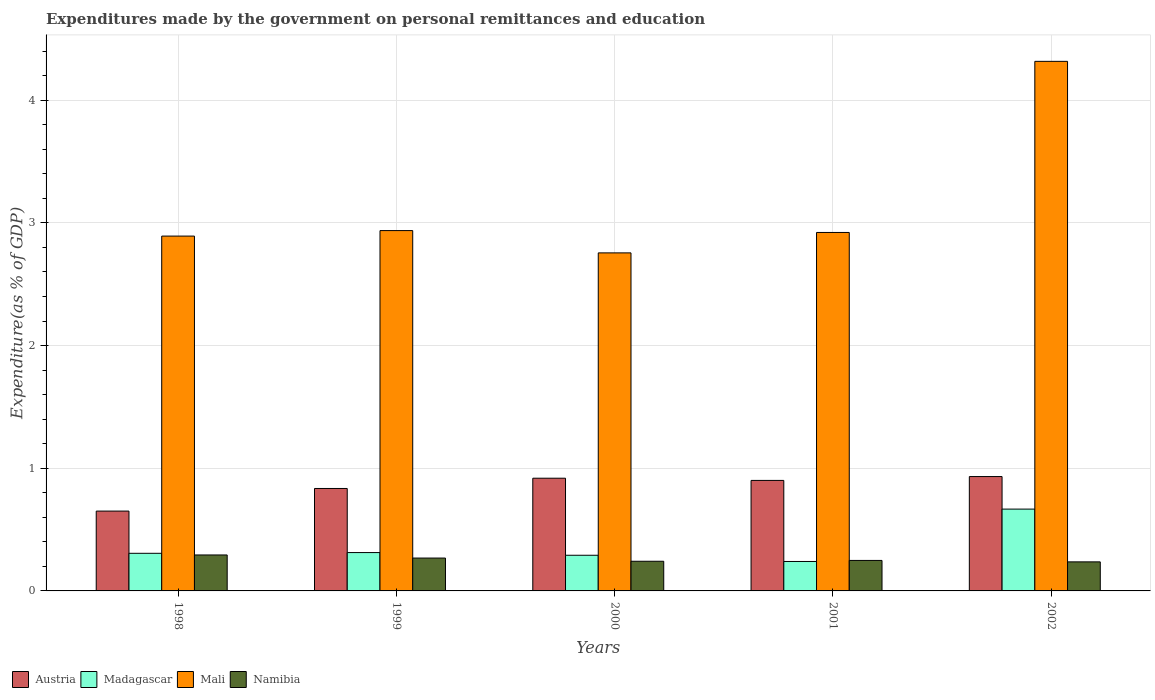How many bars are there on the 3rd tick from the right?
Your answer should be compact. 4. In how many cases, is the number of bars for a given year not equal to the number of legend labels?
Your answer should be compact. 0. What is the expenditures made by the government on personal remittances and education in Namibia in 2002?
Ensure brevity in your answer.  0.24. Across all years, what is the maximum expenditures made by the government on personal remittances and education in Madagascar?
Provide a short and direct response. 0.67. Across all years, what is the minimum expenditures made by the government on personal remittances and education in Madagascar?
Your answer should be compact. 0.24. In which year was the expenditures made by the government on personal remittances and education in Madagascar maximum?
Offer a very short reply. 2002. What is the total expenditures made by the government on personal remittances and education in Namibia in the graph?
Give a very brief answer. 1.29. What is the difference between the expenditures made by the government on personal remittances and education in Austria in 1998 and that in 1999?
Your answer should be very brief. -0.18. What is the difference between the expenditures made by the government on personal remittances and education in Austria in 1998 and the expenditures made by the government on personal remittances and education in Mali in 2001?
Your answer should be very brief. -2.27. What is the average expenditures made by the government on personal remittances and education in Madagascar per year?
Offer a very short reply. 0.36. In the year 2002, what is the difference between the expenditures made by the government on personal remittances and education in Austria and expenditures made by the government on personal remittances and education in Mali?
Your answer should be very brief. -3.38. What is the ratio of the expenditures made by the government on personal remittances and education in Madagascar in 1998 to that in 2000?
Provide a succinct answer. 1.05. Is the difference between the expenditures made by the government on personal remittances and education in Austria in 1999 and 2001 greater than the difference between the expenditures made by the government on personal remittances and education in Mali in 1999 and 2001?
Your answer should be compact. No. What is the difference between the highest and the second highest expenditures made by the government on personal remittances and education in Mali?
Your answer should be very brief. 1.38. What is the difference between the highest and the lowest expenditures made by the government on personal remittances and education in Austria?
Offer a very short reply. 0.28. In how many years, is the expenditures made by the government on personal remittances and education in Madagascar greater than the average expenditures made by the government on personal remittances and education in Madagascar taken over all years?
Your response must be concise. 1. Is the sum of the expenditures made by the government on personal remittances and education in Namibia in 2001 and 2002 greater than the maximum expenditures made by the government on personal remittances and education in Austria across all years?
Offer a terse response. No. Is it the case that in every year, the sum of the expenditures made by the government on personal remittances and education in Namibia and expenditures made by the government on personal remittances and education in Austria is greater than the sum of expenditures made by the government on personal remittances and education in Mali and expenditures made by the government on personal remittances and education in Madagascar?
Keep it short and to the point. No. What does the 4th bar from the left in 1998 represents?
Ensure brevity in your answer.  Namibia. What does the 3rd bar from the right in 1998 represents?
Provide a short and direct response. Madagascar. Is it the case that in every year, the sum of the expenditures made by the government on personal remittances and education in Madagascar and expenditures made by the government on personal remittances and education in Austria is greater than the expenditures made by the government on personal remittances and education in Namibia?
Your answer should be compact. Yes. Are all the bars in the graph horizontal?
Your answer should be very brief. No. How many years are there in the graph?
Your response must be concise. 5. Does the graph contain any zero values?
Offer a very short reply. No. How many legend labels are there?
Your answer should be compact. 4. What is the title of the graph?
Make the answer very short. Expenditures made by the government on personal remittances and education. What is the label or title of the X-axis?
Your answer should be compact. Years. What is the label or title of the Y-axis?
Your answer should be very brief. Expenditure(as % of GDP). What is the Expenditure(as % of GDP) of Austria in 1998?
Give a very brief answer. 0.65. What is the Expenditure(as % of GDP) in Madagascar in 1998?
Give a very brief answer. 0.31. What is the Expenditure(as % of GDP) in Mali in 1998?
Make the answer very short. 2.89. What is the Expenditure(as % of GDP) of Namibia in 1998?
Provide a short and direct response. 0.29. What is the Expenditure(as % of GDP) in Austria in 1999?
Your answer should be very brief. 0.84. What is the Expenditure(as % of GDP) in Madagascar in 1999?
Provide a succinct answer. 0.31. What is the Expenditure(as % of GDP) of Mali in 1999?
Provide a succinct answer. 2.94. What is the Expenditure(as % of GDP) in Namibia in 1999?
Offer a terse response. 0.27. What is the Expenditure(as % of GDP) in Austria in 2000?
Give a very brief answer. 0.92. What is the Expenditure(as % of GDP) in Madagascar in 2000?
Offer a very short reply. 0.29. What is the Expenditure(as % of GDP) of Mali in 2000?
Offer a terse response. 2.76. What is the Expenditure(as % of GDP) of Namibia in 2000?
Offer a very short reply. 0.24. What is the Expenditure(as % of GDP) of Austria in 2001?
Give a very brief answer. 0.9. What is the Expenditure(as % of GDP) in Madagascar in 2001?
Your response must be concise. 0.24. What is the Expenditure(as % of GDP) in Mali in 2001?
Provide a succinct answer. 2.92. What is the Expenditure(as % of GDP) in Namibia in 2001?
Provide a succinct answer. 0.25. What is the Expenditure(as % of GDP) in Austria in 2002?
Make the answer very short. 0.93. What is the Expenditure(as % of GDP) of Madagascar in 2002?
Your response must be concise. 0.67. What is the Expenditure(as % of GDP) of Mali in 2002?
Provide a succinct answer. 4.32. What is the Expenditure(as % of GDP) in Namibia in 2002?
Offer a very short reply. 0.24. Across all years, what is the maximum Expenditure(as % of GDP) of Austria?
Provide a short and direct response. 0.93. Across all years, what is the maximum Expenditure(as % of GDP) in Madagascar?
Keep it short and to the point. 0.67. Across all years, what is the maximum Expenditure(as % of GDP) in Mali?
Ensure brevity in your answer.  4.32. Across all years, what is the maximum Expenditure(as % of GDP) of Namibia?
Ensure brevity in your answer.  0.29. Across all years, what is the minimum Expenditure(as % of GDP) of Austria?
Your answer should be compact. 0.65. Across all years, what is the minimum Expenditure(as % of GDP) in Madagascar?
Provide a succinct answer. 0.24. Across all years, what is the minimum Expenditure(as % of GDP) of Mali?
Offer a terse response. 2.76. Across all years, what is the minimum Expenditure(as % of GDP) in Namibia?
Your response must be concise. 0.24. What is the total Expenditure(as % of GDP) of Austria in the graph?
Make the answer very short. 4.24. What is the total Expenditure(as % of GDP) in Madagascar in the graph?
Your answer should be very brief. 1.82. What is the total Expenditure(as % of GDP) of Mali in the graph?
Your answer should be very brief. 15.82. What is the total Expenditure(as % of GDP) in Namibia in the graph?
Your answer should be compact. 1.29. What is the difference between the Expenditure(as % of GDP) of Austria in 1998 and that in 1999?
Make the answer very short. -0.18. What is the difference between the Expenditure(as % of GDP) of Madagascar in 1998 and that in 1999?
Make the answer very short. -0.01. What is the difference between the Expenditure(as % of GDP) in Mali in 1998 and that in 1999?
Provide a short and direct response. -0.04. What is the difference between the Expenditure(as % of GDP) in Namibia in 1998 and that in 1999?
Your answer should be very brief. 0.03. What is the difference between the Expenditure(as % of GDP) of Austria in 1998 and that in 2000?
Your answer should be very brief. -0.27. What is the difference between the Expenditure(as % of GDP) in Madagascar in 1998 and that in 2000?
Ensure brevity in your answer.  0.02. What is the difference between the Expenditure(as % of GDP) of Mali in 1998 and that in 2000?
Offer a terse response. 0.14. What is the difference between the Expenditure(as % of GDP) of Namibia in 1998 and that in 2000?
Provide a succinct answer. 0.05. What is the difference between the Expenditure(as % of GDP) of Austria in 1998 and that in 2001?
Provide a short and direct response. -0.25. What is the difference between the Expenditure(as % of GDP) of Madagascar in 1998 and that in 2001?
Provide a succinct answer. 0.07. What is the difference between the Expenditure(as % of GDP) in Mali in 1998 and that in 2001?
Ensure brevity in your answer.  -0.03. What is the difference between the Expenditure(as % of GDP) in Namibia in 1998 and that in 2001?
Your answer should be very brief. 0.04. What is the difference between the Expenditure(as % of GDP) of Austria in 1998 and that in 2002?
Give a very brief answer. -0.28. What is the difference between the Expenditure(as % of GDP) in Madagascar in 1998 and that in 2002?
Your answer should be very brief. -0.36. What is the difference between the Expenditure(as % of GDP) in Mali in 1998 and that in 2002?
Ensure brevity in your answer.  -1.42. What is the difference between the Expenditure(as % of GDP) of Namibia in 1998 and that in 2002?
Your response must be concise. 0.06. What is the difference between the Expenditure(as % of GDP) of Austria in 1999 and that in 2000?
Your answer should be very brief. -0.08. What is the difference between the Expenditure(as % of GDP) of Madagascar in 1999 and that in 2000?
Your answer should be very brief. 0.02. What is the difference between the Expenditure(as % of GDP) in Mali in 1999 and that in 2000?
Your answer should be compact. 0.18. What is the difference between the Expenditure(as % of GDP) in Namibia in 1999 and that in 2000?
Provide a succinct answer. 0.03. What is the difference between the Expenditure(as % of GDP) of Austria in 1999 and that in 2001?
Your answer should be compact. -0.07. What is the difference between the Expenditure(as % of GDP) in Madagascar in 1999 and that in 2001?
Offer a very short reply. 0.07. What is the difference between the Expenditure(as % of GDP) in Mali in 1999 and that in 2001?
Make the answer very short. 0.02. What is the difference between the Expenditure(as % of GDP) in Namibia in 1999 and that in 2001?
Offer a terse response. 0.02. What is the difference between the Expenditure(as % of GDP) in Austria in 1999 and that in 2002?
Provide a succinct answer. -0.1. What is the difference between the Expenditure(as % of GDP) of Madagascar in 1999 and that in 2002?
Your answer should be very brief. -0.35. What is the difference between the Expenditure(as % of GDP) in Mali in 1999 and that in 2002?
Provide a short and direct response. -1.38. What is the difference between the Expenditure(as % of GDP) in Namibia in 1999 and that in 2002?
Provide a short and direct response. 0.03. What is the difference between the Expenditure(as % of GDP) of Austria in 2000 and that in 2001?
Your answer should be compact. 0.02. What is the difference between the Expenditure(as % of GDP) in Madagascar in 2000 and that in 2001?
Offer a terse response. 0.05. What is the difference between the Expenditure(as % of GDP) of Mali in 2000 and that in 2001?
Offer a very short reply. -0.17. What is the difference between the Expenditure(as % of GDP) of Namibia in 2000 and that in 2001?
Give a very brief answer. -0.01. What is the difference between the Expenditure(as % of GDP) of Austria in 2000 and that in 2002?
Give a very brief answer. -0.01. What is the difference between the Expenditure(as % of GDP) of Madagascar in 2000 and that in 2002?
Your response must be concise. -0.38. What is the difference between the Expenditure(as % of GDP) in Mali in 2000 and that in 2002?
Offer a very short reply. -1.56. What is the difference between the Expenditure(as % of GDP) in Namibia in 2000 and that in 2002?
Provide a succinct answer. 0.01. What is the difference between the Expenditure(as % of GDP) in Austria in 2001 and that in 2002?
Your response must be concise. -0.03. What is the difference between the Expenditure(as % of GDP) of Madagascar in 2001 and that in 2002?
Offer a very short reply. -0.43. What is the difference between the Expenditure(as % of GDP) of Mali in 2001 and that in 2002?
Provide a short and direct response. -1.39. What is the difference between the Expenditure(as % of GDP) in Namibia in 2001 and that in 2002?
Offer a terse response. 0.01. What is the difference between the Expenditure(as % of GDP) in Austria in 1998 and the Expenditure(as % of GDP) in Madagascar in 1999?
Offer a terse response. 0.34. What is the difference between the Expenditure(as % of GDP) in Austria in 1998 and the Expenditure(as % of GDP) in Mali in 1999?
Make the answer very short. -2.29. What is the difference between the Expenditure(as % of GDP) of Austria in 1998 and the Expenditure(as % of GDP) of Namibia in 1999?
Keep it short and to the point. 0.38. What is the difference between the Expenditure(as % of GDP) of Madagascar in 1998 and the Expenditure(as % of GDP) of Mali in 1999?
Your answer should be compact. -2.63. What is the difference between the Expenditure(as % of GDP) of Madagascar in 1998 and the Expenditure(as % of GDP) of Namibia in 1999?
Provide a short and direct response. 0.04. What is the difference between the Expenditure(as % of GDP) in Mali in 1998 and the Expenditure(as % of GDP) in Namibia in 1999?
Your response must be concise. 2.62. What is the difference between the Expenditure(as % of GDP) of Austria in 1998 and the Expenditure(as % of GDP) of Madagascar in 2000?
Your answer should be compact. 0.36. What is the difference between the Expenditure(as % of GDP) of Austria in 1998 and the Expenditure(as % of GDP) of Mali in 2000?
Your answer should be very brief. -2.1. What is the difference between the Expenditure(as % of GDP) of Austria in 1998 and the Expenditure(as % of GDP) of Namibia in 2000?
Give a very brief answer. 0.41. What is the difference between the Expenditure(as % of GDP) of Madagascar in 1998 and the Expenditure(as % of GDP) of Mali in 2000?
Offer a terse response. -2.45. What is the difference between the Expenditure(as % of GDP) of Madagascar in 1998 and the Expenditure(as % of GDP) of Namibia in 2000?
Provide a succinct answer. 0.06. What is the difference between the Expenditure(as % of GDP) in Mali in 1998 and the Expenditure(as % of GDP) in Namibia in 2000?
Offer a very short reply. 2.65. What is the difference between the Expenditure(as % of GDP) in Austria in 1998 and the Expenditure(as % of GDP) in Madagascar in 2001?
Provide a succinct answer. 0.41. What is the difference between the Expenditure(as % of GDP) of Austria in 1998 and the Expenditure(as % of GDP) of Mali in 2001?
Provide a short and direct response. -2.27. What is the difference between the Expenditure(as % of GDP) in Austria in 1998 and the Expenditure(as % of GDP) in Namibia in 2001?
Your answer should be very brief. 0.4. What is the difference between the Expenditure(as % of GDP) in Madagascar in 1998 and the Expenditure(as % of GDP) in Mali in 2001?
Provide a succinct answer. -2.62. What is the difference between the Expenditure(as % of GDP) of Madagascar in 1998 and the Expenditure(as % of GDP) of Namibia in 2001?
Provide a short and direct response. 0.06. What is the difference between the Expenditure(as % of GDP) of Mali in 1998 and the Expenditure(as % of GDP) of Namibia in 2001?
Your answer should be very brief. 2.64. What is the difference between the Expenditure(as % of GDP) of Austria in 1998 and the Expenditure(as % of GDP) of Madagascar in 2002?
Your response must be concise. -0.02. What is the difference between the Expenditure(as % of GDP) in Austria in 1998 and the Expenditure(as % of GDP) in Mali in 2002?
Provide a succinct answer. -3.67. What is the difference between the Expenditure(as % of GDP) of Austria in 1998 and the Expenditure(as % of GDP) of Namibia in 2002?
Offer a terse response. 0.41. What is the difference between the Expenditure(as % of GDP) of Madagascar in 1998 and the Expenditure(as % of GDP) of Mali in 2002?
Provide a short and direct response. -4.01. What is the difference between the Expenditure(as % of GDP) of Madagascar in 1998 and the Expenditure(as % of GDP) of Namibia in 2002?
Your response must be concise. 0.07. What is the difference between the Expenditure(as % of GDP) of Mali in 1998 and the Expenditure(as % of GDP) of Namibia in 2002?
Your answer should be compact. 2.66. What is the difference between the Expenditure(as % of GDP) of Austria in 1999 and the Expenditure(as % of GDP) of Madagascar in 2000?
Ensure brevity in your answer.  0.54. What is the difference between the Expenditure(as % of GDP) in Austria in 1999 and the Expenditure(as % of GDP) in Mali in 2000?
Your response must be concise. -1.92. What is the difference between the Expenditure(as % of GDP) in Austria in 1999 and the Expenditure(as % of GDP) in Namibia in 2000?
Your response must be concise. 0.59. What is the difference between the Expenditure(as % of GDP) of Madagascar in 1999 and the Expenditure(as % of GDP) of Mali in 2000?
Make the answer very short. -2.44. What is the difference between the Expenditure(as % of GDP) in Madagascar in 1999 and the Expenditure(as % of GDP) in Namibia in 2000?
Keep it short and to the point. 0.07. What is the difference between the Expenditure(as % of GDP) of Mali in 1999 and the Expenditure(as % of GDP) of Namibia in 2000?
Offer a very short reply. 2.7. What is the difference between the Expenditure(as % of GDP) in Austria in 1999 and the Expenditure(as % of GDP) in Madagascar in 2001?
Offer a very short reply. 0.6. What is the difference between the Expenditure(as % of GDP) of Austria in 1999 and the Expenditure(as % of GDP) of Mali in 2001?
Your answer should be compact. -2.09. What is the difference between the Expenditure(as % of GDP) in Austria in 1999 and the Expenditure(as % of GDP) in Namibia in 2001?
Your answer should be very brief. 0.59. What is the difference between the Expenditure(as % of GDP) of Madagascar in 1999 and the Expenditure(as % of GDP) of Mali in 2001?
Provide a short and direct response. -2.61. What is the difference between the Expenditure(as % of GDP) of Madagascar in 1999 and the Expenditure(as % of GDP) of Namibia in 2001?
Provide a succinct answer. 0.06. What is the difference between the Expenditure(as % of GDP) of Mali in 1999 and the Expenditure(as % of GDP) of Namibia in 2001?
Your response must be concise. 2.69. What is the difference between the Expenditure(as % of GDP) of Austria in 1999 and the Expenditure(as % of GDP) of Madagascar in 2002?
Provide a short and direct response. 0.17. What is the difference between the Expenditure(as % of GDP) in Austria in 1999 and the Expenditure(as % of GDP) in Mali in 2002?
Your response must be concise. -3.48. What is the difference between the Expenditure(as % of GDP) in Austria in 1999 and the Expenditure(as % of GDP) in Namibia in 2002?
Your answer should be very brief. 0.6. What is the difference between the Expenditure(as % of GDP) of Madagascar in 1999 and the Expenditure(as % of GDP) of Mali in 2002?
Give a very brief answer. -4. What is the difference between the Expenditure(as % of GDP) in Madagascar in 1999 and the Expenditure(as % of GDP) in Namibia in 2002?
Your response must be concise. 0.08. What is the difference between the Expenditure(as % of GDP) in Mali in 1999 and the Expenditure(as % of GDP) in Namibia in 2002?
Offer a terse response. 2.7. What is the difference between the Expenditure(as % of GDP) of Austria in 2000 and the Expenditure(as % of GDP) of Madagascar in 2001?
Make the answer very short. 0.68. What is the difference between the Expenditure(as % of GDP) in Austria in 2000 and the Expenditure(as % of GDP) in Mali in 2001?
Make the answer very short. -2. What is the difference between the Expenditure(as % of GDP) of Austria in 2000 and the Expenditure(as % of GDP) of Namibia in 2001?
Provide a short and direct response. 0.67. What is the difference between the Expenditure(as % of GDP) of Madagascar in 2000 and the Expenditure(as % of GDP) of Mali in 2001?
Your response must be concise. -2.63. What is the difference between the Expenditure(as % of GDP) of Madagascar in 2000 and the Expenditure(as % of GDP) of Namibia in 2001?
Give a very brief answer. 0.04. What is the difference between the Expenditure(as % of GDP) in Mali in 2000 and the Expenditure(as % of GDP) in Namibia in 2001?
Your answer should be very brief. 2.51. What is the difference between the Expenditure(as % of GDP) in Austria in 2000 and the Expenditure(as % of GDP) in Madagascar in 2002?
Keep it short and to the point. 0.25. What is the difference between the Expenditure(as % of GDP) in Austria in 2000 and the Expenditure(as % of GDP) in Mali in 2002?
Provide a succinct answer. -3.4. What is the difference between the Expenditure(as % of GDP) of Austria in 2000 and the Expenditure(as % of GDP) of Namibia in 2002?
Provide a succinct answer. 0.68. What is the difference between the Expenditure(as % of GDP) in Madagascar in 2000 and the Expenditure(as % of GDP) in Mali in 2002?
Your answer should be very brief. -4.03. What is the difference between the Expenditure(as % of GDP) in Madagascar in 2000 and the Expenditure(as % of GDP) in Namibia in 2002?
Give a very brief answer. 0.05. What is the difference between the Expenditure(as % of GDP) in Mali in 2000 and the Expenditure(as % of GDP) in Namibia in 2002?
Provide a succinct answer. 2.52. What is the difference between the Expenditure(as % of GDP) in Austria in 2001 and the Expenditure(as % of GDP) in Madagascar in 2002?
Provide a short and direct response. 0.23. What is the difference between the Expenditure(as % of GDP) of Austria in 2001 and the Expenditure(as % of GDP) of Mali in 2002?
Your answer should be compact. -3.42. What is the difference between the Expenditure(as % of GDP) of Austria in 2001 and the Expenditure(as % of GDP) of Namibia in 2002?
Your response must be concise. 0.66. What is the difference between the Expenditure(as % of GDP) in Madagascar in 2001 and the Expenditure(as % of GDP) in Mali in 2002?
Ensure brevity in your answer.  -4.08. What is the difference between the Expenditure(as % of GDP) in Madagascar in 2001 and the Expenditure(as % of GDP) in Namibia in 2002?
Make the answer very short. 0. What is the difference between the Expenditure(as % of GDP) in Mali in 2001 and the Expenditure(as % of GDP) in Namibia in 2002?
Provide a short and direct response. 2.68. What is the average Expenditure(as % of GDP) in Austria per year?
Your answer should be compact. 0.85. What is the average Expenditure(as % of GDP) of Madagascar per year?
Your answer should be very brief. 0.36. What is the average Expenditure(as % of GDP) of Mali per year?
Provide a short and direct response. 3.16. What is the average Expenditure(as % of GDP) of Namibia per year?
Keep it short and to the point. 0.26. In the year 1998, what is the difference between the Expenditure(as % of GDP) of Austria and Expenditure(as % of GDP) of Madagascar?
Offer a terse response. 0.34. In the year 1998, what is the difference between the Expenditure(as % of GDP) in Austria and Expenditure(as % of GDP) in Mali?
Offer a very short reply. -2.24. In the year 1998, what is the difference between the Expenditure(as % of GDP) in Austria and Expenditure(as % of GDP) in Namibia?
Make the answer very short. 0.36. In the year 1998, what is the difference between the Expenditure(as % of GDP) of Madagascar and Expenditure(as % of GDP) of Mali?
Give a very brief answer. -2.59. In the year 1998, what is the difference between the Expenditure(as % of GDP) of Madagascar and Expenditure(as % of GDP) of Namibia?
Offer a terse response. 0.01. In the year 1998, what is the difference between the Expenditure(as % of GDP) in Mali and Expenditure(as % of GDP) in Namibia?
Provide a succinct answer. 2.6. In the year 1999, what is the difference between the Expenditure(as % of GDP) of Austria and Expenditure(as % of GDP) of Madagascar?
Your answer should be very brief. 0.52. In the year 1999, what is the difference between the Expenditure(as % of GDP) of Austria and Expenditure(as % of GDP) of Mali?
Your response must be concise. -2.1. In the year 1999, what is the difference between the Expenditure(as % of GDP) in Austria and Expenditure(as % of GDP) in Namibia?
Ensure brevity in your answer.  0.57. In the year 1999, what is the difference between the Expenditure(as % of GDP) in Madagascar and Expenditure(as % of GDP) in Mali?
Make the answer very short. -2.62. In the year 1999, what is the difference between the Expenditure(as % of GDP) of Madagascar and Expenditure(as % of GDP) of Namibia?
Your response must be concise. 0.04. In the year 1999, what is the difference between the Expenditure(as % of GDP) of Mali and Expenditure(as % of GDP) of Namibia?
Make the answer very short. 2.67. In the year 2000, what is the difference between the Expenditure(as % of GDP) in Austria and Expenditure(as % of GDP) in Madagascar?
Provide a short and direct response. 0.63. In the year 2000, what is the difference between the Expenditure(as % of GDP) in Austria and Expenditure(as % of GDP) in Mali?
Give a very brief answer. -1.84. In the year 2000, what is the difference between the Expenditure(as % of GDP) of Austria and Expenditure(as % of GDP) of Namibia?
Your answer should be very brief. 0.68. In the year 2000, what is the difference between the Expenditure(as % of GDP) in Madagascar and Expenditure(as % of GDP) in Mali?
Your answer should be compact. -2.46. In the year 2000, what is the difference between the Expenditure(as % of GDP) in Madagascar and Expenditure(as % of GDP) in Namibia?
Ensure brevity in your answer.  0.05. In the year 2000, what is the difference between the Expenditure(as % of GDP) of Mali and Expenditure(as % of GDP) of Namibia?
Ensure brevity in your answer.  2.51. In the year 2001, what is the difference between the Expenditure(as % of GDP) in Austria and Expenditure(as % of GDP) in Madagascar?
Offer a very short reply. 0.66. In the year 2001, what is the difference between the Expenditure(as % of GDP) in Austria and Expenditure(as % of GDP) in Mali?
Keep it short and to the point. -2.02. In the year 2001, what is the difference between the Expenditure(as % of GDP) in Austria and Expenditure(as % of GDP) in Namibia?
Offer a terse response. 0.65. In the year 2001, what is the difference between the Expenditure(as % of GDP) in Madagascar and Expenditure(as % of GDP) in Mali?
Ensure brevity in your answer.  -2.68. In the year 2001, what is the difference between the Expenditure(as % of GDP) in Madagascar and Expenditure(as % of GDP) in Namibia?
Offer a very short reply. -0.01. In the year 2001, what is the difference between the Expenditure(as % of GDP) of Mali and Expenditure(as % of GDP) of Namibia?
Your answer should be very brief. 2.67. In the year 2002, what is the difference between the Expenditure(as % of GDP) in Austria and Expenditure(as % of GDP) in Madagascar?
Ensure brevity in your answer.  0.27. In the year 2002, what is the difference between the Expenditure(as % of GDP) in Austria and Expenditure(as % of GDP) in Mali?
Provide a short and direct response. -3.38. In the year 2002, what is the difference between the Expenditure(as % of GDP) in Austria and Expenditure(as % of GDP) in Namibia?
Your answer should be very brief. 0.7. In the year 2002, what is the difference between the Expenditure(as % of GDP) in Madagascar and Expenditure(as % of GDP) in Mali?
Your answer should be very brief. -3.65. In the year 2002, what is the difference between the Expenditure(as % of GDP) of Madagascar and Expenditure(as % of GDP) of Namibia?
Ensure brevity in your answer.  0.43. In the year 2002, what is the difference between the Expenditure(as % of GDP) of Mali and Expenditure(as % of GDP) of Namibia?
Ensure brevity in your answer.  4.08. What is the ratio of the Expenditure(as % of GDP) of Austria in 1998 to that in 1999?
Keep it short and to the point. 0.78. What is the ratio of the Expenditure(as % of GDP) in Madagascar in 1998 to that in 1999?
Offer a very short reply. 0.98. What is the ratio of the Expenditure(as % of GDP) of Mali in 1998 to that in 1999?
Offer a very short reply. 0.98. What is the ratio of the Expenditure(as % of GDP) of Namibia in 1998 to that in 1999?
Your answer should be compact. 1.09. What is the ratio of the Expenditure(as % of GDP) of Austria in 1998 to that in 2000?
Keep it short and to the point. 0.71. What is the ratio of the Expenditure(as % of GDP) of Madagascar in 1998 to that in 2000?
Make the answer very short. 1.05. What is the ratio of the Expenditure(as % of GDP) of Mali in 1998 to that in 2000?
Your answer should be very brief. 1.05. What is the ratio of the Expenditure(as % of GDP) in Namibia in 1998 to that in 2000?
Make the answer very short. 1.21. What is the ratio of the Expenditure(as % of GDP) of Austria in 1998 to that in 2001?
Ensure brevity in your answer.  0.72. What is the ratio of the Expenditure(as % of GDP) in Madagascar in 1998 to that in 2001?
Offer a very short reply. 1.28. What is the ratio of the Expenditure(as % of GDP) in Namibia in 1998 to that in 2001?
Keep it short and to the point. 1.18. What is the ratio of the Expenditure(as % of GDP) in Austria in 1998 to that in 2002?
Ensure brevity in your answer.  0.7. What is the ratio of the Expenditure(as % of GDP) in Madagascar in 1998 to that in 2002?
Offer a very short reply. 0.46. What is the ratio of the Expenditure(as % of GDP) of Mali in 1998 to that in 2002?
Your response must be concise. 0.67. What is the ratio of the Expenditure(as % of GDP) in Namibia in 1998 to that in 2002?
Keep it short and to the point. 1.24. What is the ratio of the Expenditure(as % of GDP) of Austria in 1999 to that in 2000?
Your answer should be compact. 0.91. What is the ratio of the Expenditure(as % of GDP) of Madagascar in 1999 to that in 2000?
Keep it short and to the point. 1.08. What is the ratio of the Expenditure(as % of GDP) in Mali in 1999 to that in 2000?
Keep it short and to the point. 1.07. What is the ratio of the Expenditure(as % of GDP) of Namibia in 1999 to that in 2000?
Your answer should be compact. 1.11. What is the ratio of the Expenditure(as % of GDP) in Austria in 1999 to that in 2001?
Offer a very short reply. 0.93. What is the ratio of the Expenditure(as % of GDP) of Madagascar in 1999 to that in 2001?
Offer a terse response. 1.3. What is the ratio of the Expenditure(as % of GDP) of Namibia in 1999 to that in 2001?
Your response must be concise. 1.08. What is the ratio of the Expenditure(as % of GDP) of Austria in 1999 to that in 2002?
Provide a short and direct response. 0.9. What is the ratio of the Expenditure(as % of GDP) of Madagascar in 1999 to that in 2002?
Provide a succinct answer. 0.47. What is the ratio of the Expenditure(as % of GDP) of Mali in 1999 to that in 2002?
Provide a succinct answer. 0.68. What is the ratio of the Expenditure(as % of GDP) of Namibia in 1999 to that in 2002?
Make the answer very short. 1.13. What is the ratio of the Expenditure(as % of GDP) of Madagascar in 2000 to that in 2001?
Offer a terse response. 1.21. What is the ratio of the Expenditure(as % of GDP) in Mali in 2000 to that in 2001?
Provide a succinct answer. 0.94. What is the ratio of the Expenditure(as % of GDP) of Namibia in 2000 to that in 2001?
Your answer should be compact. 0.97. What is the ratio of the Expenditure(as % of GDP) in Austria in 2000 to that in 2002?
Your response must be concise. 0.99. What is the ratio of the Expenditure(as % of GDP) in Madagascar in 2000 to that in 2002?
Offer a terse response. 0.44. What is the ratio of the Expenditure(as % of GDP) in Mali in 2000 to that in 2002?
Offer a very short reply. 0.64. What is the ratio of the Expenditure(as % of GDP) of Austria in 2001 to that in 2002?
Offer a very short reply. 0.97. What is the ratio of the Expenditure(as % of GDP) in Madagascar in 2001 to that in 2002?
Give a very brief answer. 0.36. What is the ratio of the Expenditure(as % of GDP) of Mali in 2001 to that in 2002?
Ensure brevity in your answer.  0.68. What is the ratio of the Expenditure(as % of GDP) of Namibia in 2001 to that in 2002?
Offer a very short reply. 1.05. What is the difference between the highest and the second highest Expenditure(as % of GDP) in Austria?
Offer a very short reply. 0.01. What is the difference between the highest and the second highest Expenditure(as % of GDP) of Madagascar?
Ensure brevity in your answer.  0.35. What is the difference between the highest and the second highest Expenditure(as % of GDP) of Mali?
Keep it short and to the point. 1.38. What is the difference between the highest and the second highest Expenditure(as % of GDP) in Namibia?
Give a very brief answer. 0.03. What is the difference between the highest and the lowest Expenditure(as % of GDP) in Austria?
Your answer should be very brief. 0.28. What is the difference between the highest and the lowest Expenditure(as % of GDP) of Madagascar?
Give a very brief answer. 0.43. What is the difference between the highest and the lowest Expenditure(as % of GDP) of Mali?
Your answer should be very brief. 1.56. What is the difference between the highest and the lowest Expenditure(as % of GDP) of Namibia?
Keep it short and to the point. 0.06. 